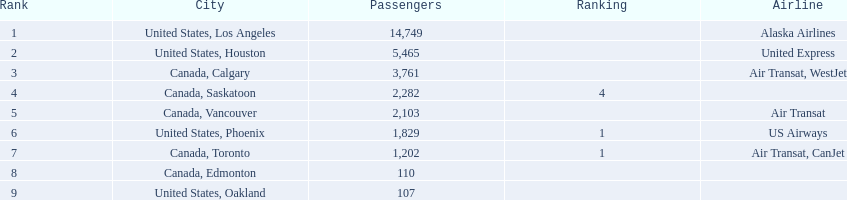Where are the destinations of the airport? United States, Los Angeles, United States, Houston, Canada, Calgary, Canada, Saskatoon, Canada, Vancouver, United States, Phoenix, Canada, Toronto, Canada, Edmonton, United States, Oakland. What is the number of passengers to phoenix? 1,829. 